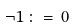<formula> <loc_0><loc_0><loc_500><loc_500>\neg 1 \, \colon = \, 0</formula> 